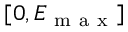Convert formula to latex. <formula><loc_0><loc_0><loc_500><loc_500>[ 0 , E _ { m a x } ]</formula> 